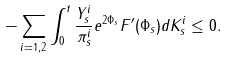<formula> <loc_0><loc_0><loc_500><loc_500>- \sum _ { i = 1 , 2 } \int _ { 0 } ^ { t } \frac { Y ^ { i } _ { s } } { \pi ^ { i } _ { s } } e ^ { 2 \Phi _ { s } } F ^ { \prime } ( \Phi _ { s } ) d K ^ { i } _ { s } \leq 0 .</formula> 